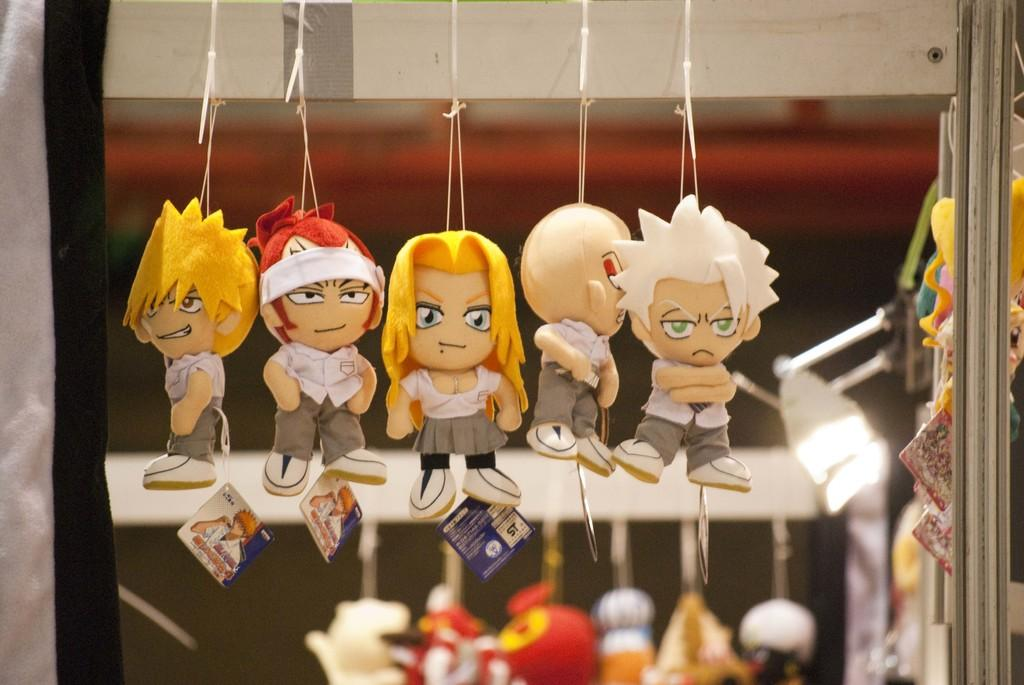What type of objects are present in the image? There are mini toys in the image. What can be found on the mini toys? The mini toys have tags. Can you describe the background of the image? There are more toys in the background of the image. What is located at the right side of the image? There is a pole at the right side of the image. How would you describe the appearance of the backdrop? The backdrop is blurred. What type of bone can be seen in the image? There is no bone present in the image; it features mini toys with tags and a blurred backdrop. 